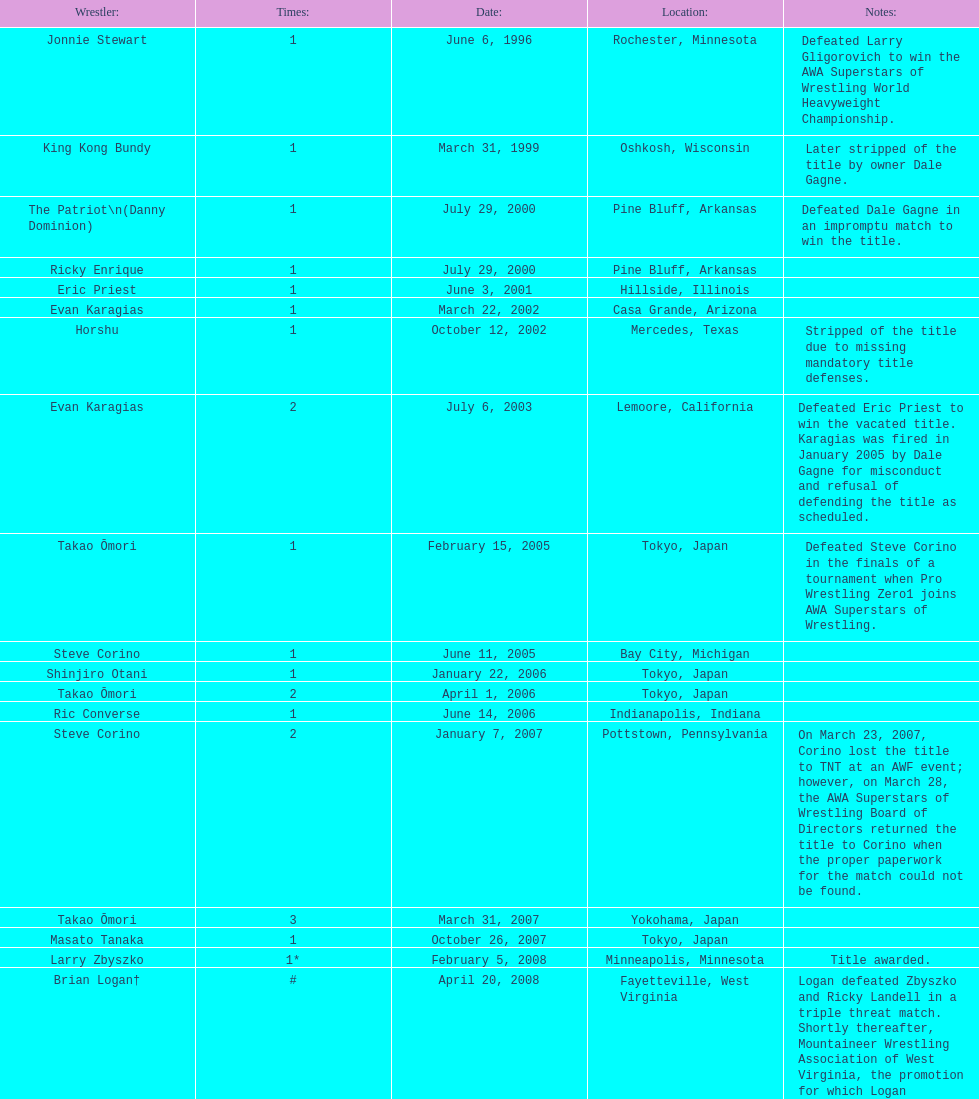In what year did steve corino secure his initial wsl title? June 11, 2005. 